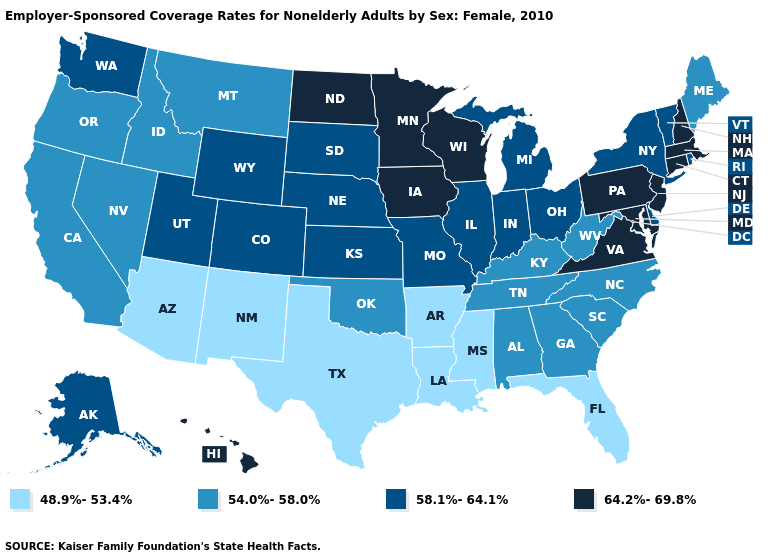Among the states that border Massachusetts , does Vermont have the lowest value?
Write a very short answer. Yes. What is the highest value in the Northeast ?
Short answer required. 64.2%-69.8%. What is the value of Georgia?
Write a very short answer. 54.0%-58.0%. Does the first symbol in the legend represent the smallest category?
Short answer required. Yes. Does Illinois have a higher value than Maryland?
Concise answer only. No. What is the lowest value in the Northeast?
Answer briefly. 54.0%-58.0%. Which states have the lowest value in the West?
Give a very brief answer. Arizona, New Mexico. Does Pennsylvania have the highest value in the USA?
Quick response, please. Yes. Name the states that have a value in the range 58.1%-64.1%?
Be succinct. Alaska, Colorado, Delaware, Illinois, Indiana, Kansas, Michigan, Missouri, Nebraska, New York, Ohio, Rhode Island, South Dakota, Utah, Vermont, Washington, Wyoming. Among the states that border North Dakota , does South Dakota have the highest value?
Keep it brief. No. Among the states that border South Dakota , does Wyoming have the highest value?
Answer briefly. No. Name the states that have a value in the range 54.0%-58.0%?
Give a very brief answer. Alabama, California, Georgia, Idaho, Kentucky, Maine, Montana, Nevada, North Carolina, Oklahoma, Oregon, South Carolina, Tennessee, West Virginia. Does New Hampshire have the highest value in the USA?
Be succinct. Yes. Which states have the lowest value in the MidWest?
Concise answer only. Illinois, Indiana, Kansas, Michigan, Missouri, Nebraska, Ohio, South Dakota. What is the value of Wyoming?
Concise answer only. 58.1%-64.1%. 